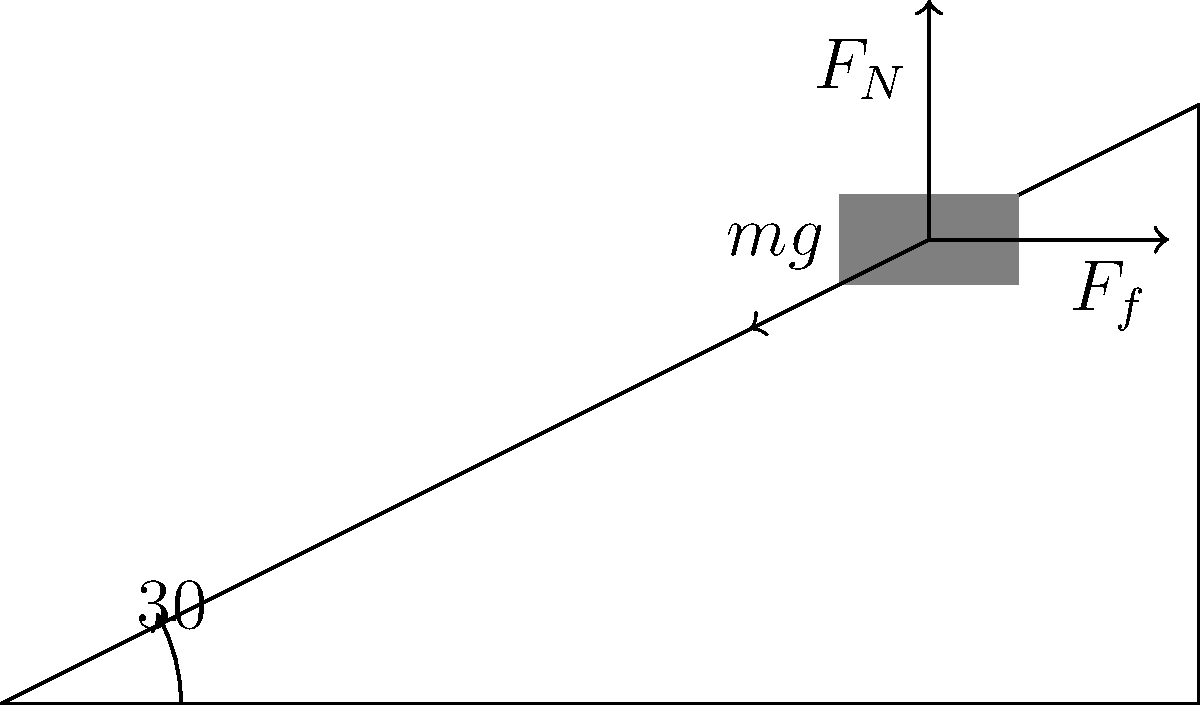Um bloco de massa $m = 5 \text{ kg}$ está em repouso em um plano inclinado com ângulo de $30°$ em relação à horizontal. O coeficiente de atrito estático entre o bloco e o plano é $\mu_s = 0,3$. Determine a força de atrito $F_f$ que atua no bloco. Para resolver este problema, vamos seguir os seguintes passos:

1) Identificar as forças atuando no bloco:
   - Peso ($mg$)
   - Força Normal ($F_N$)
   - Força de Atrito ($F_f$)

2) Decompor o peso nas direções paralela e perpendicular ao plano:
   - Componente paralela: $mg \sin 30°$
   - Componente perpendicular: $mg \cos 30°$

3) Como o bloco está em repouso, a soma das forças paralelas ao plano deve ser zero:
   $F_f = mg \sin 30°$

4) A força normal é igual à componente perpendicular do peso:
   $F_N = mg \cos 30°$

5) Sabemos que a força de atrito máxima é dada por:
   $F_f = \mu_s F_N$

6) Substituindo os valores:
   $F_f = mg \sin 30° = 5 \cdot 9.8 \cdot \sin 30° = 24.5 \text{ N}$

7) Verificamos se esta força é menor que a força de atrito máxima:
   $F_{f,max} = \mu_s F_N = 0.3 \cdot (5 \cdot 9.8 \cdot \cos 30°) = 12.74 \text{ N}$

8) Como $F_f > F_{f,max}$, o bloco não pode estar em repouso com este coeficiente de atrito.

9) Portanto, a força de atrito será igual à força de atrito máxima:
   $F_f = 12.74 \text{ N}$
Answer: $12.74 \text{ N}$ 